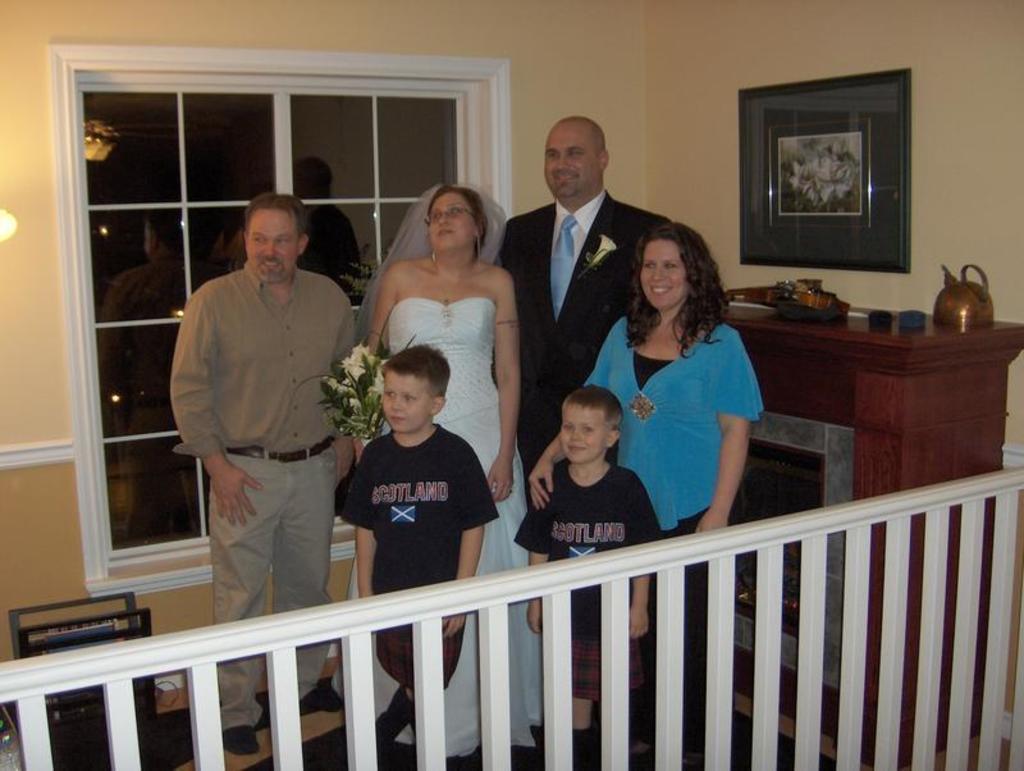Describe this image in one or two sentences. There are people standing and we can see some objects on table. Background we can see frame on wall,window and light. Here we can see fence. 